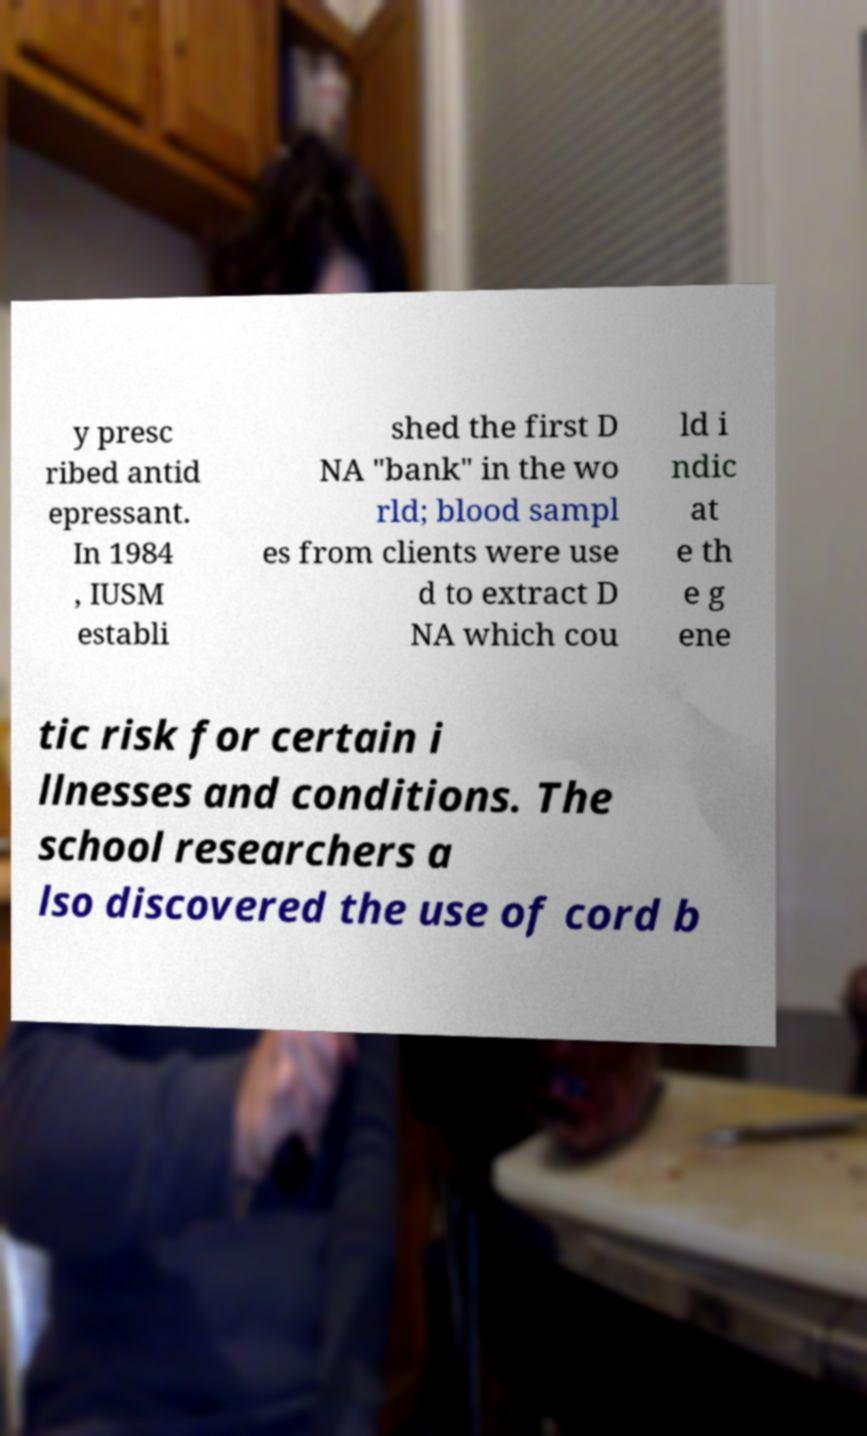Please read and relay the text visible in this image. What does it say? y presc ribed antid epressant. In 1984 , IUSM establi shed the first D NA "bank" in the wo rld; blood sampl es from clients were use d to extract D NA which cou ld i ndic at e th e g ene tic risk for certain i llnesses and conditions. The school researchers a lso discovered the use of cord b 